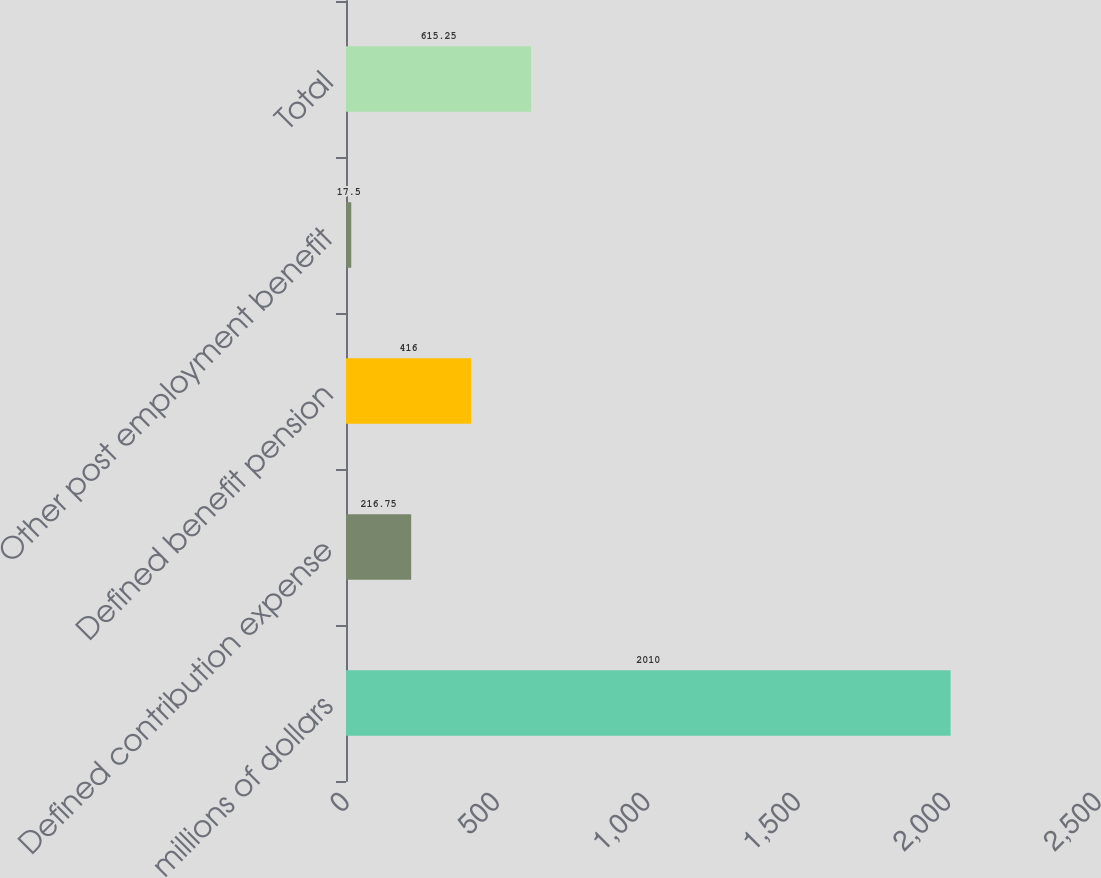Convert chart. <chart><loc_0><loc_0><loc_500><loc_500><bar_chart><fcel>millions of dollars<fcel>Defined contribution expense<fcel>Defined benefit pension<fcel>Other post employment benefit<fcel>Total<nl><fcel>2010<fcel>216.75<fcel>416<fcel>17.5<fcel>615.25<nl></chart> 